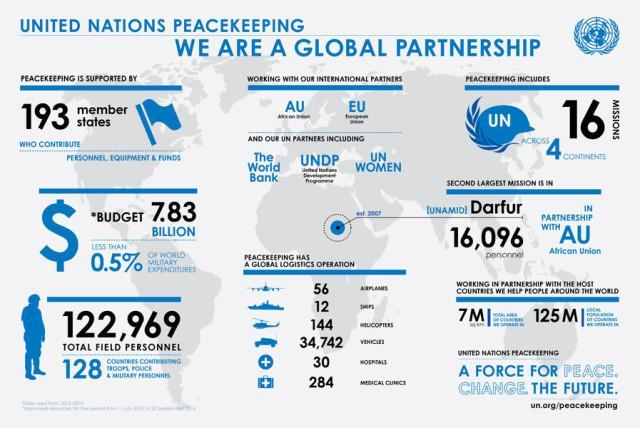How many countries do not contribute troops, police or military for peacekeeping missions?
Answer the question with a short phrase. 67 What is the total number of hospitals and medical clinics used in Global Logistics Operation? 314 How many international partners does UN have for peacekeeping mission? 2 Which UN partner is involved in peacekeeping missions, UNICEF, UNCTAD, or UNDP? UNDP How many UN partners are involved in peacekeeping missions? 3 